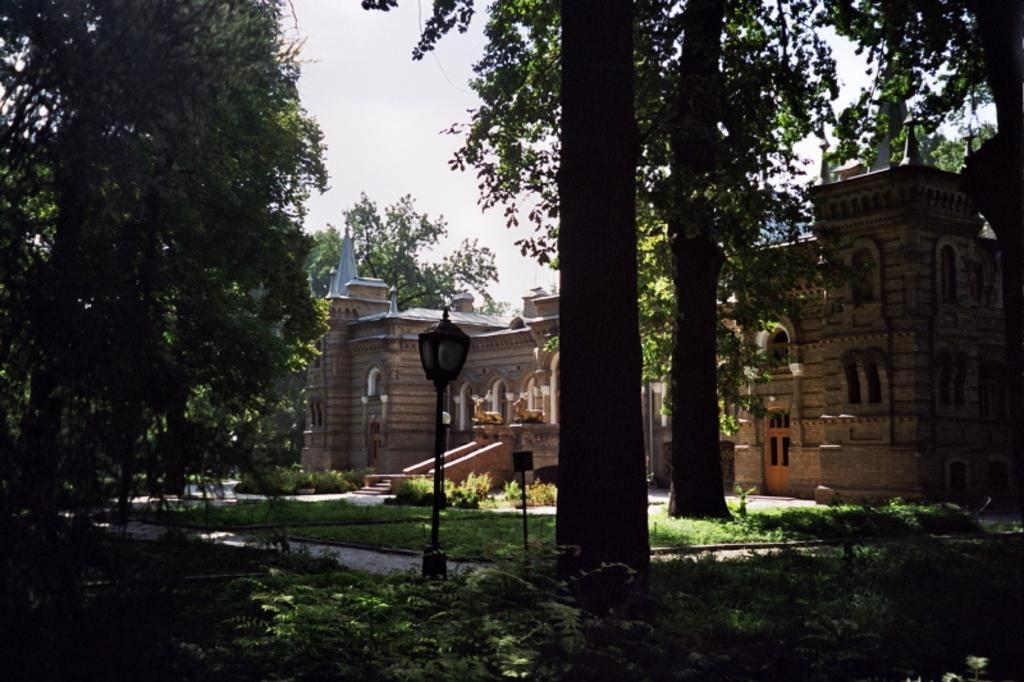What is the main subject in the center of the image? There is a light pole and a group of trees in the center of the image. Can you describe the building in the background? There is a building with windows in the background. What can be seen in the sky in the background? The sky is visible in the background. How many sticks are being used by the secretary in the image? There is no secretary or sticks present in the image. 